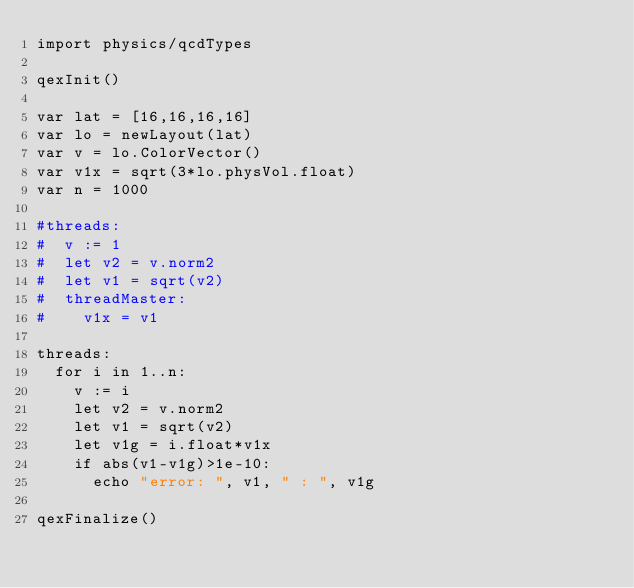Convert code to text. <code><loc_0><loc_0><loc_500><loc_500><_Nim_>import physics/qcdTypes

qexInit()

var lat = [16,16,16,16]
var lo = newLayout(lat)
var v = lo.ColorVector()
var v1x = sqrt(3*lo.physVol.float)
var n = 1000

#threads:
#  v := 1
#  let v2 = v.norm2
#  let v1 = sqrt(v2)
#  threadMaster:
#    v1x = v1

threads:
  for i in 1..n:
    v := i
    let v2 = v.norm2
    let v1 = sqrt(v2)
    let v1g = i.float*v1x
    if abs(v1-v1g)>1e-10:
      echo "error: ", v1, " : ", v1g

qexFinalize()
</code> 